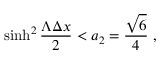Convert formula to latex. <formula><loc_0><loc_0><loc_500><loc_500>\sinh ^ { 2 } { \frac { \Lambda \Delta x } { 2 } } < a _ { 2 } = { \frac { \sqrt { 6 } } { 4 } } \ ,</formula> 